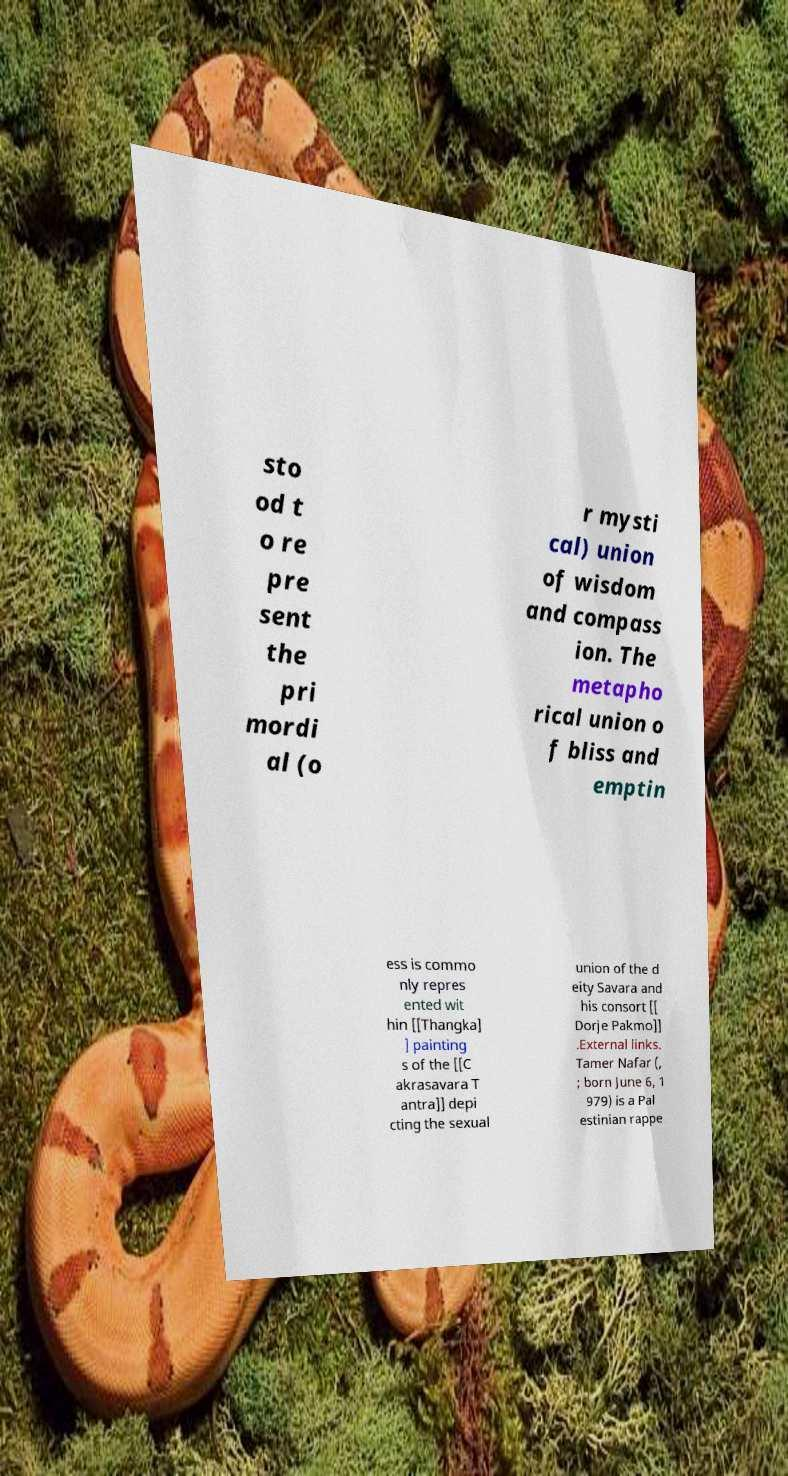Can you accurately transcribe the text from the provided image for me? sto od t o re pre sent the pri mordi al (o r mysti cal) union of wisdom and compass ion. The metapho rical union o f bliss and emptin ess is commo nly repres ented wit hin [[Thangka] ] painting s of the [[C akrasavara T antra]] depi cting the sexual union of the d eity Savara and his consort [[ Dorje Pakmo]] .External links. Tamer Nafar (, ; born June 6, 1 979) is a Pal estinian rappe 